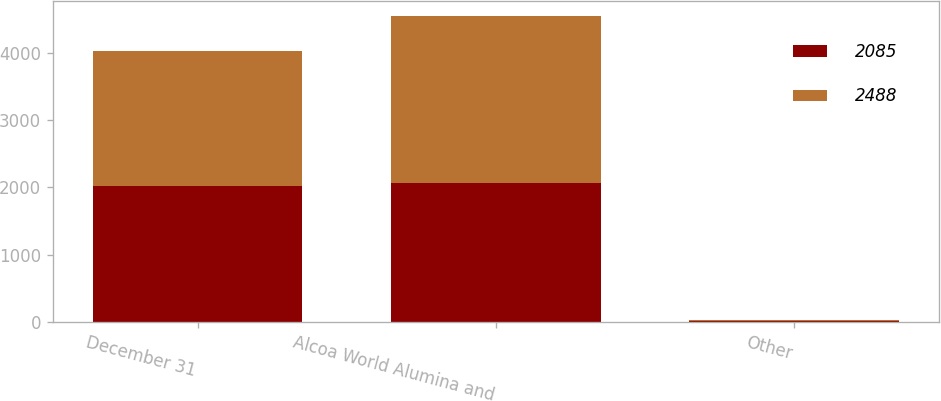<chart> <loc_0><loc_0><loc_500><loc_500><stacked_bar_chart><ecel><fcel>December 31<fcel>Alcoa World Alumina and<fcel>Other<nl><fcel>2085<fcel>2015<fcel>2071<fcel>14<nl><fcel>2488<fcel>2014<fcel>2474<fcel>14<nl></chart> 